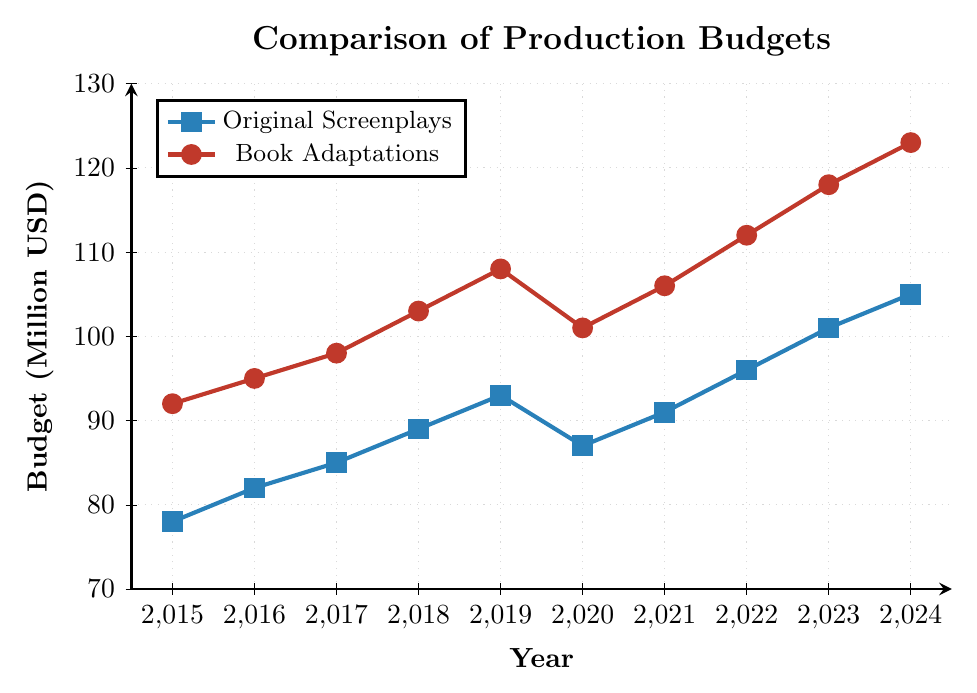What's the average budget for book adaptations over the period? First, sum the budgets of book adaptations for each year: 92 + 95 + 98 + 103 + 108 + 101 + 106 + 112 + 118 + 123 = 1056. Then, divide by the number of years, which is 10. The average budget is 1056/10 = 105.6 million USD.
Answer: 105.6 million USD How much more did studios spend on book adaptations than original screenplays in 2023? For 2023, the budget for book adaptations is 118 million USD and for original screenplays is 101 million USD. The difference is 118 - 101 = 17 million USD.
Answer: 17 million USD Which year had the smallest difference in budgets between original screenplays and book adaptations? Calculate the differences for each year: 2015: 92-78=14, 2016: 95-82=13, 2017: 98-85=13, 2018: 103-89=14, 2019: 108-93=15, 2020: 101-87=14, 2021: 106-91=15, 2022: 112-96=16, 2023: 118-101=17, 2024: 123-105=18. The smallest difference is in 2016 and 2017 with 13 million USD.
Answer: 2016 and 2017 By how much did the budget for original screenplays increase from 2015 to 2024? The budget for original screenplays in 2015 was 78 million USD, and in 2024 it is projected to be 105 million USD. The increase is 105 - 78 = 27 million USD.
Answer: 27 million USD Is there any year where the budget for original screenplays decreased compared to the previous year? Compare each year's budget for original screenplays to the previous year: from 2015 to 2016 (78 to 82), from 2016 to 2017 (82 to 85), from 2017 to 2018 (85 to 89), from 2018 to 2019 (89 to 93), from 2019 to 2020 (93 to 87), reducing by 6 million USD. Thus, in 2020, the budget decreased.
Answer: 2020 What's the total spending on original screenplays and book adaptations in 2022? For 2022, sum up the budgets for original screenplays (96 million USD) and book adaptations (112 million USD): 96 + 112 = 208 million USD.
Answer: 208 million USD How does the trend of production budgets for book adaptations compare to that of original screenplays? Both trends generally show an upward trajectory from 2015 to 2024. However, book adaptations consistently have higher budgets each year, and the gap between the two tends to widen over time.
Answer: Both trends are upward, but book adaptations are consistently higher What was the percentage increase in the budget for book adaptations from 2015 to 2024? The budget in 2015 was 92 million USD and in 2024 it is projected to be 123 million USD. Percentage increase = [(123 - 92) / 92] * 100 = (31 / 92) * 100 ≈ 33.7%.
Answer: 33.7% 